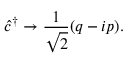<formula> <loc_0><loc_0><loc_500><loc_500>\hat { c } ^ { \dagger } \to \frac { 1 } { \sqrt { 2 } } ( q - i p ) .</formula> 